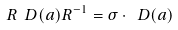Convert formula to latex. <formula><loc_0><loc_0><loc_500><loc_500>R \ D ( a ) R ^ { - 1 } = \sigma \cdot \ D ( a )</formula> 